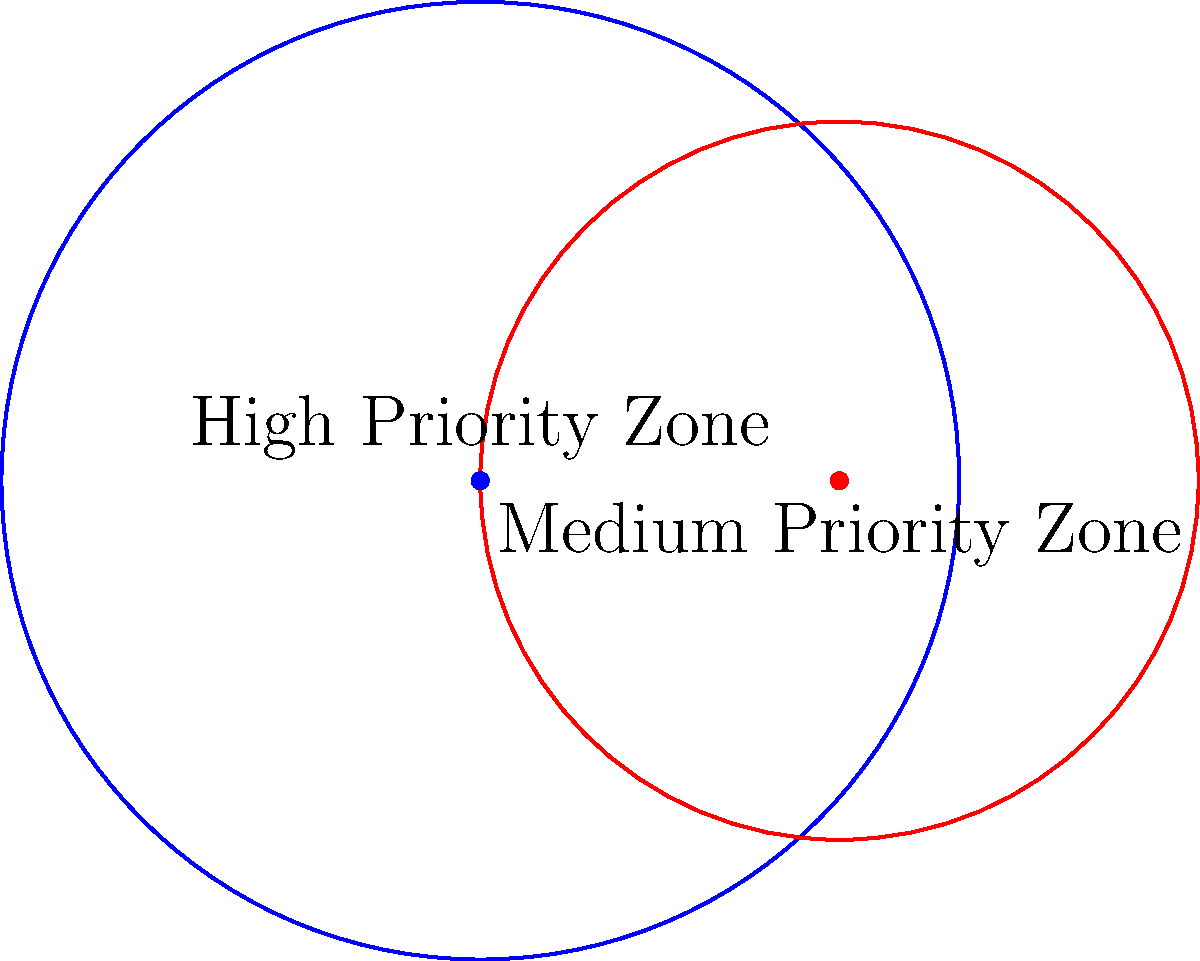In a conservation area, two circular zones represent different levels of protection priority. The high priority zone has a radius of 4 km, while the medium priority zone has a radius of 3 km. If the centers of these zones are 3 km apart, what is the area of the region where the two zones overlap? (Use $\pi = 3.14$ and round your answer to two decimal places.) To solve this problem, we'll use the formula for the area of overlapping circles:

1) First, calculate the distance $d$ between the centers of the circles:
   $d = 3$ km (given in the question)

2) Use the formula for the area of intersection:
   $A = r_1^2 \arccos(\frac{d^2 + r_1^2 - r_2^2}{2dr_1}) + r_2^2 \arccos(\frac{d^2 + r_2^2 - r_1^2}{2dr_2}) - \frac{1}{2}\sqrt{(-d+r_1+r_2)(d+r_1-r_2)(d-r_1+r_2)(d+r_1+r_2)}$

   Where:
   $r_1 = 4$ km (radius of high priority zone)
   $r_2 = 3$ km (radius of medium priority zone)
   $d = 3$ km (distance between centers)

3) Substitute these values:
   $A = 4^2 \arccos(\frac{3^2 + 4^2 - 3^2}{2 \cdot 3 \cdot 4}) + 3^2 \arccos(\frac{3^2 + 3^2 - 4^2}{2 \cdot 3 \cdot 3}) - \frac{1}{2}\sqrt{(-3+4+3)(3+4-3)(3-4+3)(3+4+3)}$

4) Simplify:
   $A = 16 \arccos(\frac{25}{24}) + 9 \arccos(\frac{10}{18}) - \frac{1}{2}\sqrt{4 \cdot 4 \cdot 2 \cdot 10}$

5) Calculate:
   $A \approx 16 \cdot 0.2838 + 9 \cdot 1.0472 - \frac{1}{2}\sqrt{320}$
   $A \approx 4.5408 + 9.4248 - 8.9443$
   $A \approx 5.0213$ km²

6) Round to two decimal places:
   $A \approx 5.02$ km²
Answer: 5.02 km² 